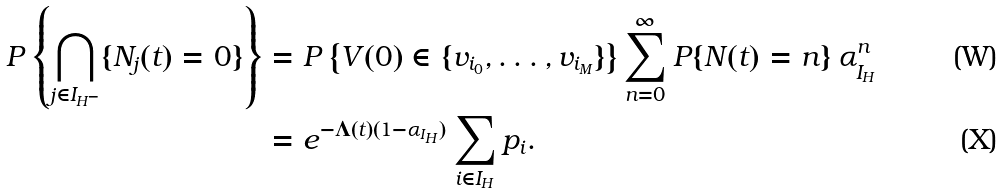<formula> <loc_0><loc_0><loc_500><loc_500>P \left \{ \bigcap _ { j \in I _ { H ^ { - } } } \{ N _ { j } ( t ) = 0 \} \right \} & = P \left \{ V ( 0 ) \in \{ v _ { i _ { 0 } } , \dots , v _ { i _ { M } } \} \right \} \sum _ { n = 0 } ^ { \infty } P \{ N ( t ) = n \} \, \alpha _ { I _ { H } } ^ { n } \\ & = e ^ { - \Lambda ( t ) ( 1 - \alpha _ { I _ { H } } ) } \sum _ { i \in I _ { H } } p _ { i } .</formula> 